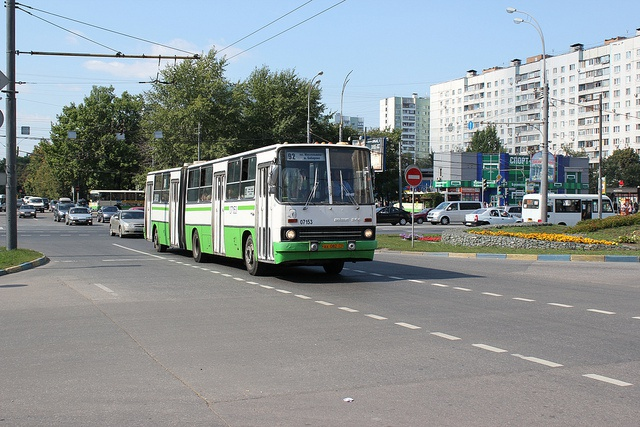Describe the objects in this image and their specific colors. I can see bus in lightblue, black, white, gray, and darkgray tones, bus in lightblue, darkgray, black, white, and gray tones, bus in lightblue, black, gray, ivory, and darkgray tones, truck in lightblue, darkgray, black, and lightgray tones, and car in lightblue, darkgray, black, gray, and darkblue tones in this image. 